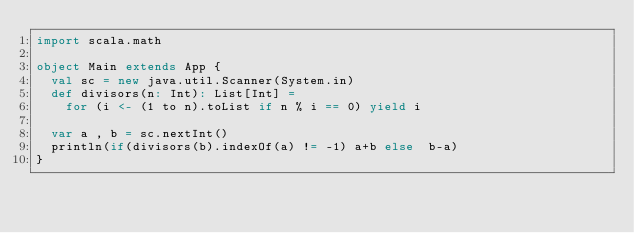Convert code to text. <code><loc_0><loc_0><loc_500><loc_500><_Scala_>import scala.math

object Main extends App {
  val sc = new java.util.Scanner(System.in)
  def divisors(n: Int): List[Int] =
    for (i <- (1 to n).toList if n % i == 0) yield i

  var a , b = sc.nextInt()
  println(if(divisors(b).indexOf(a) != -1) a+b else  b-a)
}
</code> 